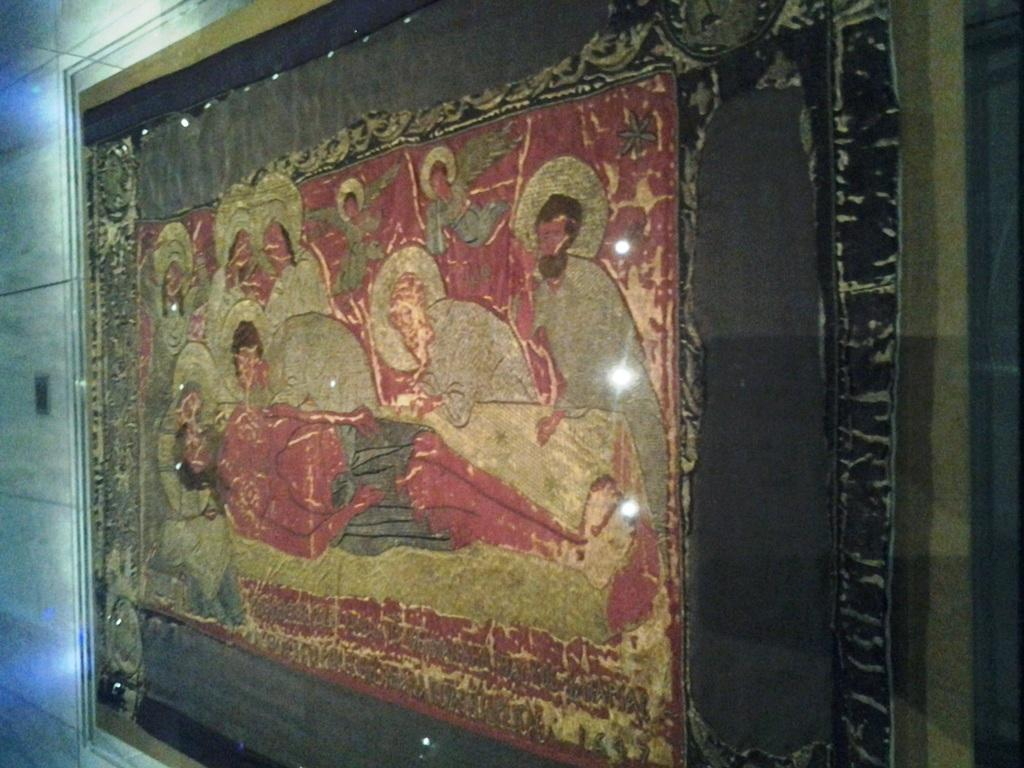What is the main subject of the image? There is a painting in the image. What can be seen in the painting? There are people in the painting. What is the dominant color of the painting? The painting is predominantly red in color. What is visible in the background of the image? There is a wall in the background of the image. Can you tell me how many rocks are present in the painting? There are no rocks depicted in the painting; it features people in a predominantly red environment. What type of wing is shown on the people in the painting? The people in the painting do not have wings; they are depicted without any such appendages. 